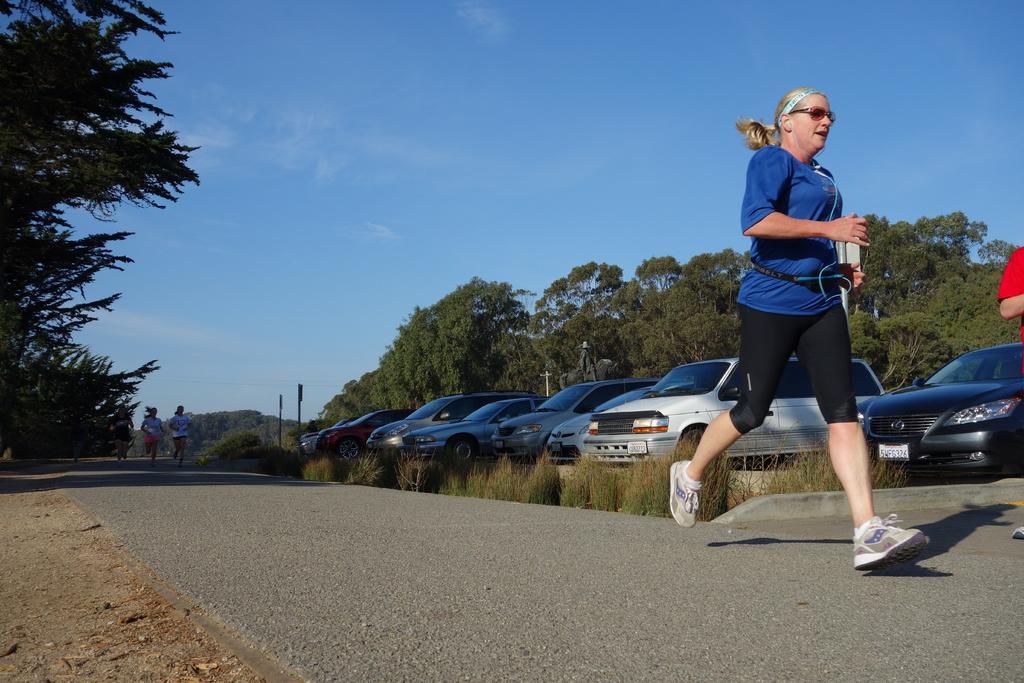Could you give a brief overview of what you see in this image? In this image I can see the group of people running on the road. These people are wearing the different color dresses. To the side these people I can see many vehicles and the poles. In the background there are many trees and the blue sky. 